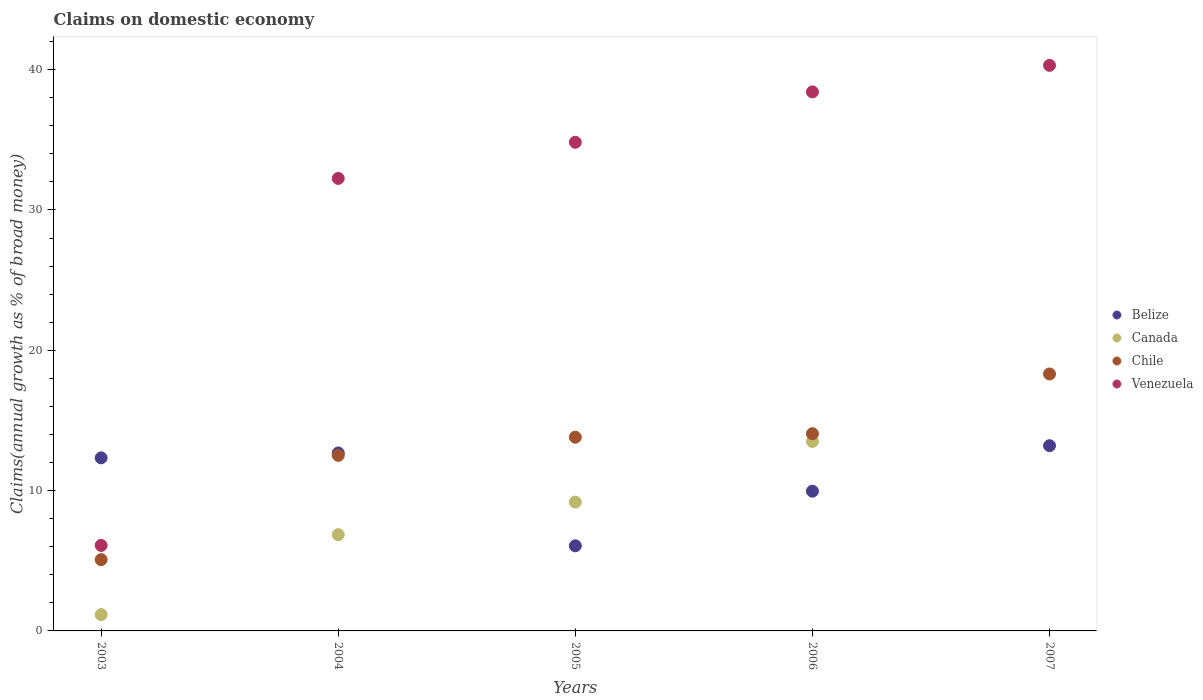What is the percentage of broad money claimed on domestic economy in Canada in 2003?
Offer a terse response. 1.16. Across all years, what is the maximum percentage of broad money claimed on domestic economy in Canada?
Provide a succinct answer. 13.5. Across all years, what is the minimum percentage of broad money claimed on domestic economy in Chile?
Provide a succinct answer. 5.08. What is the total percentage of broad money claimed on domestic economy in Canada in the graph?
Offer a terse response. 30.71. What is the difference between the percentage of broad money claimed on domestic economy in Venezuela in 2003 and that in 2005?
Provide a succinct answer. -28.73. What is the difference between the percentage of broad money claimed on domestic economy in Canada in 2004 and the percentage of broad money claimed on domestic economy in Belize in 2003?
Your answer should be very brief. -5.47. What is the average percentage of broad money claimed on domestic economy in Belize per year?
Your answer should be very brief. 10.85. In the year 2004, what is the difference between the percentage of broad money claimed on domestic economy in Venezuela and percentage of broad money claimed on domestic economy in Belize?
Your answer should be compact. 19.57. In how many years, is the percentage of broad money claimed on domestic economy in Venezuela greater than 40 %?
Ensure brevity in your answer.  1. What is the ratio of the percentage of broad money claimed on domestic economy in Belize in 2006 to that in 2007?
Provide a short and direct response. 0.75. What is the difference between the highest and the second highest percentage of broad money claimed on domestic economy in Canada?
Offer a terse response. 4.32. What is the difference between the highest and the lowest percentage of broad money claimed on domestic economy in Belize?
Provide a short and direct response. 7.14. Is it the case that in every year, the sum of the percentage of broad money claimed on domestic economy in Venezuela and percentage of broad money claimed on domestic economy in Chile  is greater than the sum of percentage of broad money claimed on domestic economy in Canada and percentage of broad money claimed on domestic economy in Belize?
Offer a terse response. No. Does the percentage of broad money claimed on domestic economy in Chile monotonically increase over the years?
Offer a very short reply. Yes. How many years are there in the graph?
Ensure brevity in your answer.  5. What is the difference between two consecutive major ticks on the Y-axis?
Keep it short and to the point. 10. Does the graph contain any zero values?
Give a very brief answer. Yes. Does the graph contain grids?
Provide a short and direct response. No. How many legend labels are there?
Offer a terse response. 4. What is the title of the graph?
Make the answer very short. Claims on domestic economy. Does "Montenegro" appear as one of the legend labels in the graph?
Your answer should be very brief. No. What is the label or title of the X-axis?
Provide a succinct answer. Years. What is the label or title of the Y-axis?
Give a very brief answer. Claims(annual growth as % of broad money). What is the Claims(annual growth as % of broad money) of Belize in 2003?
Your answer should be compact. 12.33. What is the Claims(annual growth as % of broad money) in Canada in 2003?
Ensure brevity in your answer.  1.16. What is the Claims(annual growth as % of broad money) of Chile in 2003?
Give a very brief answer. 5.08. What is the Claims(annual growth as % of broad money) of Venezuela in 2003?
Keep it short and to the point. 6.09. What is the Claims(annual growth as % of broad money) of Belize in 2004?
Provide a short and direct response. 12.68. What is the Claims(annual growth as % of broad money) of Canada in 2004?
Offer a terse response. 6.86. What is the Claims(annual growth as % of broad money) in Chile in 2004?
Give a very brief answer. 12.51. What is the Claims(annual growth as % of broad money) of Venezuela in 2004?
Your response must be concise. 32.25. What is the Claims(annual growth as % of broad money) of Belize in 2005?
Your answer should be compact. 6.07. What is the Claims(annual growth as % of broad money) in Canada in 2005?
Your response must be concise. 9.18. What is the Claims(annual growth as % of broad money) of Chile in 2005?
Keep it short and to the point. 13.81. What is the Claims(annual growth as % of broad money) of Venezuela in 2005?
Offer a very short reply. 34.83. What is the Claims(annual growth as % of broad money) in Belize in 2006?
Offer a very short reply. 9.96. What is the Claims(annual growth as % of broad money) of Canada in 2006?
Keep it short and to the point. 13.5. What is the Claims(annual growth as % of broad money) in Chile in 2006?
Offer a terse response. 14.06. What is the Claims(annual growth as % of broad money) in Venezuela in 2006?
Provide a short and direct response. 38.42. What is the Claims(annual growth as % of broad money) in Belize in 2007?
Your answer should be compact. 13.2. What is the Claims(annual growth as % of broad money) of Canada in 2007?
Provide a short and direct response. 0. What is the Claims(annual growth as % of broad money) of Chile in 2007?
Your response must be concise. 18.31. What is the Claims(annual growth as % of broad money) of Venezuela in 2007?
Give a very brief answer. 40.31. Across all years, what is the maximum Claims(annual growth as % of broad money) in Belize?
Make the answer very short. 13.2. Across all years, what is the maximum Claims(annual growth as % of broad money) in Canada?
Your answer should be compact. 13.5. Across all years, what is the maximum Claims(annual growth as % of broad money) of Chile?
Keep it short and to the point. 18.31. Across all years, what is the maximum Claims(annual growth as % of broad money) of Venezuela?
Give a very brief answer. 40.31. Across all years, what is the minimum Claims(annual growth as % of broad money) of Belize?
Ensure brevity in your answer.  6.07. Across all years, what is the minimum Claims(annual growth as % of broad money) in Chile?
Offer a terse response. 5.08. Across all years, what is the minimum Claims(annual growth as % of broad money) of Venezuela?
Provide a short and direct response. 6.09. What is the total Claims(annual growth as % of broad money) of Belize in the graph?
Give a very brief answer. 54.24. What is the total Claims(annual growth as % of broad money) in Canada in the graph?
Give a very brief answer. 30.71. What is the total Claims(annual growth as % of broad money) of Chile in the graph?
Ensure brevity in your answer.  63.77. What is the total Claims(annual growth as % of broad money) of Venezuela in the graph?
Provide a short and direct response. 151.89. What is the difference between the Claims(annual growth as % of broad money) of Belize in 2003 and that in 2004?
Make the answer very short. -0.35. What is the difference between the Claims(annual growth as % of broad money) of Canada in 2003 and that in 2004?
Make the answer very short. -5.7. What is the difference between the Claims(annual growth as % of broad money) in Chile in 2003 and that in 2004?
Provide a succinct answer. -7.43. What is the difference between the Claims(annual growth as % of broad money) of Venezuela in 2003 and that in 2004?
Provide a succinct answer. -26.16. What is the difference between the Claims(annual growth as % of broad money) in Belize in 2003 and that in 2005?
Give a very brief answer. 6.27. What is the difference between the Claims(annual growth as % of broad money) in Canada in 2003 and that in 2005?
Provide a short and direct response. -8.02. What is the difference between the Claims(annual growth as % of broad money) in Chile in 2003 and that in 2005?
Give a very brief answer. -8.73. What is the difference between the Claims(annual growth as % of broad money) of Venezuela in 2003 and that in 2005?
Ensure brevity in your answer.  -28.73. What is the difference between the Claims(annual growth as % of broad money) of Belize in 2003 and that in 2006?
Provide a succinct answer. 2.38. What is the difference between the Claims(annual growth as % of broad money) of Canada in 2003 and that in 2006?
Give a very brief answer. -12.34. What is the difference between the Claims(annual growth as % of broad money) of Chile in 2003 and that in 2006?
Your response must be concise. -8.98. What is the difference between the Claims(annual growth as % of broad money) in Venezuela in 2003 and that in 2006?
Give a very brief answer. -32.32. What is the difference between the Claims(annual growth as % of broad money) in Belize in 2003 and that in 2007?
Your answer should be compact. -0.87. What is the difference between the Claims(annual growth as % of broad money) in Chile in 2003 and that in 2007?
Your answer should be very brief. -13.23. What is the difference between the Claims(annual growth as % of broad money) in Venezuela in 2003 and that in 2007?
Your answer should be very brief. -34.21. What is the difference between the Claims(annual growth as % of broad money) in Belize in 2004 and that in 2005?
Offer a very short reply. 6.62. What is the difference between the Claims(annual growth as % of broad money) of Canada in 2004 and that in 2005?
Your answer should be compact. -2.32. What is the difference between the Claims(annual growth as % of broad money) of Chile in 2004 and that in 2005?
Keep it short and to the point. -1.29. What is the difference between the Claims(annual growth as % of broad money) in Venezuela in 2004 and that in 2005?
Your answer should be compact. -2.58. What is the difference between the Claims(annual growth as % of broad money) of Belize in 2004 and that in 2006?
Ensure brevity in your answer.  2.72. What is the difference between the Claims(annual growth as % of broad money) in Canada in 2004 and that in 2006?
Keep it short and to the point. -6.64. What is the difference between the Claims(annual growth as % of broad money) in Chile in 2004 and that in 2006?
Your answer should be compact. -1.54. What is the difference between the Claims(annual growth as % of broad money) of Venezuela in 2004 and that in 2006?
Provide a succinct answer. -6.17. What is the difference between the Claims(annual growth as % of broad money) in Belize in 2004 and that in 2007?
Provide a succinct answer. -0.52. What is the difference between the Claims(annual growth as % of broad money) of Chile in 2004 and that in 2007?
Provide a succinct answer. -5.8. What is the difference between the Claims(annual growth as % of broad money) in Venezuela in 2004 and that in 2007?
Give a very brief answer. -8.06. What is the difference between the Claims(annual growth as % of broad money) of Belize in 2005 and that in 2006?
Your answer should be compact. -3.89. What is the difference between the Claims(annual growth as % of broad money) of Canada in 2005 and that in 2006?
Provide a succinct answer. -4.32. What is the difference between the Claims(annual growth as % of broad money) in Chile in 2005 and that in 2006?
Give a very brief answer. -0.25. What is the difference between the Claims(annual growth as % of broad money) in Venezuela in 2005 and that in 2006?
Offer a very short reply. -3.59. What is the difference between the Claims(annual growth as % of broad money) of Belize in 2005 and that in 2007?
Ensure brevity in your answer.  -7.14. What is the difference between the Claims(annual growth as % of broad money) of Chile in 2005 and that in 2007?
Your response must be concise. -4.51. What is the difference between the Claims(annual growth as % of broad money) in Venezuela in 2005 and that in 2007?
Give a very brief answer. -5.48. What is the difference between the Claims(annual growth as % of broad money) of Belize in 2006 and that in 2007?
Your response must be concise. -3.24. What is the difference between the Claims(annual growth as % of broad money) of Chile in 2006 and that in 2007?
Offer a very short reply. -4.25. What is the difference between the Claims(annual growth as % of broad money) in Venezuela in 2006 and that in 2007?
Your response must be concise. -1.89. What is the difference between the Claims(annual growth as % of broad money) of Belize in 2003 and the Claims(annual growth as % of broad money) of Canada in 2004?
Offer a very short reply. 5.47. What is the difference between the Claims(annual growth as % of broad money) of Belize in 2003 and the Claims(annual growth as % of broad money) of Chile in 2004?
Make the answer very short. -0.18. What is the difference between the Claims(annual growth as % of broad money) in Belize in 2003 and the Claims(annual growth as % of broad money) in Venezuela in 2004?
Provide a short and direct response. -19.92. What is the difference between the Claims(annual growth as % of broad money) of Canada in 2003 and the Claims(annual growth as % of broad money) of Chile in 2004?
Ensure brevity in your answer.  -11.35. What is the difference between the Claims(annual growth as % of broad money) in Canada in 2003 and the Claims(annual growth as % of broad money) in Venezuela in 2004?
Make the answer very short. -31.09. What is the difference between the Claims(annual growth as % of broad money) in Chile in 2003 and the Claims(annual growth as % of broad money) in Venezuela in 2004?
Provide a succinct answer. -27.17. What is the difference between the Claims(annual growth as % of broad money) in Belize in 2003 and the Claims(annual growth as % of broad money) in Canada in 2005?
Provide a short and direct response. 3.15. What is the difference between the Claims(annual growth as % of broad money) in Belize in 2003 and the Claims(annual growth as % of broad money) in Chile in 2005?
Offer a very short reply. -1.47. What is the difference between the Claims(annual growth as % of broad money) of Belize in 2003 and the Claims(annual growth as % of broad money) of Venezuela in 2005?
Give a very brief answer. -22.49. What is the difference between the Claims(annual growth as % of broad money) in Canada in 2003 and the Claims(annual growth as % of broad money) in Chile in 2005?
Provide a short and direct response. -12.64. What is the difference between the Claims(annual growth as % of broad money) of Canada in 2003 and the Claims(annual growth as % of broad money) of Venezuela in 2005?
Provide a short and direct response. -33.66. What is the difference between the Claims(annual growth as % of broad money) in Chile in 2003 and the Claims(annual growth as % of broad money) in Venezuela in 2005?
Give a very brief answer. -29.75. What is the difference between the Claims(annual growth as % of broad money) in Belize in 2003 and the Claims(annual growth as % of broad money) in Canada in 2006?
Ensure brevity in your answer.  -1.17. What is the difference between the Claims(annual growth as % of broad money) in Belize in 2003 and the Claims(annual growth as % of broad money) in Chile in 2006?
Provide a short and direct response. -1.72. What is the difference between the Claims(annual growth as % of broad money) in Belize in 2003 and the Claims(annual growth as % of broad money) in Venezuela in 2006?
Keep it short and to the point. -26.08. What is the difference between the Claims(annual growth as % of broad money) in Canada in 2003 and the Claims(annual growth as % of broad money) in Chile in 2006?
Your answer should be very brief. -12.89. What is the difference between the Claims(annual growth as % of broad money) in Canada in 2003 and the Claims(annual growth as % of broad money) in Venezuela in 2006?
Offer a terse response. -37.25. What is the difference between the Claims(annual growth as % of broad money) of Chile in 2003 and the Claims(annual growth as % of broad money) of Venezuela in 2006?
Provide a succinct answer. -33.34. What is the difference between the Claims(annual growth as % of broad money) of Belize in 2003 and the Claims(annual growth as % of broad money) of Chile in 2007?
Your answer should be compact. -5.98. What is the difference between the Claims(annual growth as % of broad money) of Belize in 2003 and the Claims(annual growth as % of broad money) of Venezuela in 2007?
Your answer should be compact. -27.97. What is the difference between the Claims(annual growth as % of broad money) in Canada in 2003 and the Claims(annual growth as % of broad money) in Chile in 2007?
Keep it short and to the point. -17.15. What is the difference between the Claims(annual growth as % of broad money) in Canada in 2003 and the Claims(annual growth as % of broad money) in Venezuela in 2007?
Give a very brief answer. -39.15. What is the difference between the Claims(annual growth as % of broad money) in Chile in 2003 and the Claims(annual growth as % of broad money) in Venezuela in 2007?
Keep it short and to the point. -35.23. What is the difference between the Claims(annual growth as % of broad money) in Belize in 2004 and the Claims(annual growth as % of broad money) in Canada in 2005?
Provide a succinct answer. 3.5. What is the difference between the Claims(annual growth as % of broad money) in Belize in 2004 and the Claims(annual growth as % of broad money) in Chile in 2005?
Give a very brief answer. -1.12. What is the difference between the Claims(annual growth as % of broad money) in Belize in 2004 and the Claims(annual growth as % of broad money) in Venezuela in 2005?
Your response must be concise. -22.14. What is the difference between the Claims(annual growth as % of broad money) in Canada in 2004 and the Claims(annual growth as % of broad money) in Chile in 2005?
Offer a very short reply. -6.95. What is the difference between the Claims(annual growth as % of broad money) in Canada in 2004 and the Claims(annual growth as % of broad money) in Venezuela in 2005?
Offer a very short reply. -27.96. What is the difference between the Claims(annual growth as % of broad money) of Chile in 2004 and the Claims(annual growth as % of broad money) of Venezuela in 2005?
Make the answer very short. -22.31. What is the difference between the Claims(annual growth as % of broad money) of Belize in 2004 and the Claims(annual growth as % of broad money) of Canada in 2006?
Ensure brevity in your answer.  -0.82. What is the difference between the Claims(annual growth as % of broad money) of Belize in 2004 and the Claims(annual growth as % of broad money) of Chile in 2006?
Offer a very short reply. -1.37. What is the difference between the Claims(annual growth as % of broad money) in Belize in 2004 and the Claims(annual growth as % of broad money) in Venezuela in 2006?
Provide a succinct answer. -25.73. What is the difference between the Claims(annual growth as % of broad money) in Canada in 2004 and the Claims(annual growth as % of broad money) in Chile in 2006?
Offer a terse response. -7.2. What is the difference between the Claims(annual growth as % of broad money) of Canada in 2004 and the Claims(annual growth as % of broad money) of Venezuela in 2006?
Provide a succinct answer. -31.55. What is the difference between the Claims(annual growth as % of broad money) in Chile in 2004 and the Claims(annual growth as % of broad money) in Venezuela in 2006?
Offer a very short reply. -25.9. What is the difference between the Claims(annual growth as % of broad money) of Belize in 2004 and the Claims(annual growth as % of broad money) of Chile in 2007?
Give a very brief answer. -5.63. What is the difference between the Claims(annual growth as % of broad money) of Belize in 2004 and the Claims(annual growth as % of broad money) of Venezuela in 2007?
Provide a short and direct response. -27.63. What is the difference between the Claims(annual growth as % of broad money) in Canada in 2004 and the Claims(annual growth as % of broad money) in Chile in 2007?
Provide a succinct answer. -11.45. What is the difference between the Claims(annual growth as % of broad money) in Canada in 2004 and the Claims(annual growth as % of broad money) in Venezuela in 2007?
Ensure brevity in your answer.  -33.45. What is the difference between the Claims(annual growth as % of broad money) in Chile in 2004 and the Claims(annual growth as % of broad money) in Venezuela in 2007?
Make the answer very short. -27.8. What is the difference between the Claims(annual growth as % of broad money) of Belize in 2005 and the Claims(annual growth as % of broad money) of Canada in 2006?
Give a very brief answer. -7.44. What is the difference between the Claims(annual growth as % of broad money) of Belize in 2005 and the Claims(annual growth as % of broad money) of Chile in 2006?
Your answer should be compact. -7.99. What is the difference between the Claims(annual growth as % of broad money) of Belize in 2005 and the Claims(annual growth as % of broad money) of Venezuela in 2006?
Offer a terse response. -32.35. What is the difference between the Claims(annual growth as % of broad money) of Canada in 2005 and the Claims(annual growth as % of broad money) of Chile in 2006?
Your answer should be compact. -4.88. What is the difference between the Claims(annual growth as % of broad money) in Canada in 2005 and the Claims(annual growth as % of broad money) in Venezuela in 2006?
Provide a succinct answer. -29.23. What is the difference between the Claims(annual growth as % of broad money) of Chile in 2005 and the Claims(annual growth as % of broad money) of Venezuela in 2006?
Ensure brevity in your answer.  -24.61. What is the difference between the Claims(annual growth as % of broad money) in Belize in 2005 and the Claims(annual growth as % of broad money) in Chile in 2007?
Make the answer very short. -12.25. What is the difference between the Claims(annual growth as % of broad money) in Belize in 2005 and the Claims(annual growth as % of broad money) in Venezuela in 2007?
Provide a succinct answer. -34.24. What is the difference between the Claims(annual growth as % of broad money) of Canada in 2005 and the Claims(annual growth as % of broad money) of Chile in 2007?
Your answer should be very brief. -9.13. What is the difference between the Claims(annual growth as % of broad money) of Canada in 2005 and the Claims(annual growth as % of broad money) of Venezuela in 2007?
Keep it short and to the point. -31.13. What is the difference between the Claims(annual growth as % of broad money) in Chile in 2005 and the Claims(annual growth as % of broad money) in Venezuela in 2007?
Ensure brevity in your answer.  -26.5. What is the difference between the Claims(annual growth as % of broad money) of Belize in 2006 and the Claims(annual growth as % of broad money) of Chile in 2007?
Your response must be concise. -8.35. What is the difference between the Claims(annual growth as % of broad money) in Belize in 2006 and the Claims(annual growth as % of broad money) in Venezuela in 2007?
Make the answer very short. -30.35. What is the difference between the Claims(annual growth as % of broad money) of Canada in 2006 and the Claims(annual growth as % of broad money) of Chile in 2007?
Ensure brevity in your answer.  -4.81. What is the difference between the Claims(annual growth as % of broad money) in Canada in 2006 and the Claims(annual growth as % of broad money) in Venezuela in 2007?
Give a very brief answer. -26.8. What is the difference between the Claims(annual growth as % of broad money) in Chile in 2006 and the Claims(annual growth as % of broad money) in Venezuela in 2007?
Offer a very short reply. -26.25. What is the average Claims(annual growth as % of broad money) in Belize per year?
Ensure brevity in your answer.  10.85. What is the average Claims(annual growth as % of broad money) in Canada per year?
Provide a short and direct response. 6.14. What is the average Claims(annual growth as % of broad money) in Chile per year?
Offer a very short reply. 12.75. What is the average Claims(annual growth as % of broad money) of Venezuela per year?
Provide a short and direct response. 30.38. In the year 2003, what is the difference between the Claims(annual growth as % of broad money) in Belize and Claims(annual growth as % of broad money) in Canada?
Provide a short and direct response. 11.17. In the year 2003, what is the difference between the Claims(annual growth as % of broad money) of Belize and Claims(annual growth as % of broad money) of Chile?
Your answer should be very brief. 7.25. In the year 2003, what is the difference between the Claims(annual growth as % of broad money) of Belize and Claims(annual growth as % of broad money) of Venezuela?
Your response must be concise. 6.24. In the year 2003, what is the difference between the Claims(annual growth as % of broad money) in Canada and Claims(annual growth as % of broad money) in Chile?
Provide a succinct answer. -3.92. In the year 2003, what is the difference between the Claims(annual growth as % of broad money) of Canada and Claims(annual growth as % of broad money) of Venezuela?
Keep it short and to the point. -4.93. In the year 2003, what is the difference between the Claims(annual growth as % of broad money) of Chile and Claims(annual growth as % of broad money) of Venezuela?
Your answer should be compact. -1.01. In the year 2004, what is the difference between the Claims(annual growth as % of broad money) of Belize and Claims(annual growth as % of broad money) of Canada?
Offer a very short reply. 5.82. In the year 2004, what is the difference between the Claims(annual growth as % of broad money) of Belize and Claims(annual growth as % of broad money) of Chile?
Your answer should be compact. 0.17. In the year 2004, what is the difference between the Claims(annual growth as % of broad money) in Belize and Claims(annual growth as % of broad money) in Venezuela?
Ensure brevity in your answer.  -19.57. In the year 2004, what is the difference between the Claims(annual growth as % of broad money) in Canada and Claims(annual growth as % of broad money) in Chile?
Ensure brevity in your answer.  -5.65. In the year 2004, what is the difference between the Claims(annual growth as % of broad money) in Canada and Claims(annual growth as % of broad money) in Venezuela?
Offer a terse response. -25.39. In the year 2004, what is the difference between the Claims(annual growth as % of broad money) in Chile and Claims(annual growth as % of broad money) in Venezuela?
Ensure brevity in your answer.  -19.74. In the year 2005, what is the difference between the Claims(annual growth as % of broad money) in Belize and Claims(annual growth as % of broad money) in Canada?
Give a very brief answer. -3.11. In the year 2005, what is the difference between the Claims(annual growth as % of broad money) of Belize and Claims(annual growth as % of broad money) of Chile?
Your answer should be compact. -7.74. In the year 2005, what is the difference between the Claims(annual growth as % of broad money) of Belize and Claims(annual growth as % of broad money) of Venezuela?
Ensure brevity in your answer.  -28.76. In the year 2005, what is the difference between the Claims(annual growth as % of broad money) in Canada and Claims(annual growth as % of broad money) in Chile?
Make the answer very short. -4.63. In the year 2005, what is the difference between the Claims(annual growth as % of broad money) of Canada and Claims(annual growth as % of broad money) of Venezuela?
Your answer should be compact. -25.64. In the year 2005, what is the difference between the Claims(annual growth as % of broad money) of Chile and Claims(annual growth as % of broad money) of Venezuela?
Make the answer very short. -21.02. In the year 2006, what is the difference between the Claims(annual growth as % of broad money) in Belize and Claims(annual growth as % of broad money) in Canada?
Your response must be concise. -3.55. In the year 2006, what is the difference between the Claims(annual growth as % of broad money) of Belize and Claims(annual growth as % of broad money) of Chile?
Give a very brief answer. -4.1. In the year 2006, what is the difference between the Claims(annual growth as % of broad money) in Belize and Claims(annual growth as % of broad money) in Venezuela?
Make the answer very short. -28.46. In the year 2006, what is the difference between the Claims(annual growth as % of broad money) of Canada and Claims(annual growth as % of broad money) of Chile?
Your response must be concise. -0.55. In the year 2006, what is the difference between the Claims(annual growth as % of broad money) of Canada and Claims(annual growth as % of broad money) of Venezuela?
Your answer should be compact. -24.91. In the year 2006, what is the difference between the Claims(annual growth as % of broad money) of Chile and Claims(annual growth as % of broad money) of Venezuela?
Offer a terse response. -24.36. In the year 2007, what is the difference between the Claims(annual growth as % of broad money) in Belize and Claims(annual growth as % of broad money) in Chile?
Ensure brevity in your answer.  -5.11. In the year 2007, what is the difference between the Claims(annual growth as % of broad money) in Belize and Claims(annual growth as % of broad money) in Venezuela?
Make the answer very short. -27.11. In the year 2007, what is the difference between the Claims(annual growth as % of broad money) of Chile and Claims(annual growth as % of broad money) of Venezuela?
Make the answer very short. -22. What is the ratio of the Claims(annual growth as % of broad money) in Belize in 2003 to that in 2004?
Provide a succinct answer. 0.97. What is the ratio of the Claims(annual growth as % of broad money) of Canada in 2003 to that in 2004?
Your answer should be very brief. 0.17. What is the ratio of the Claims(annual growth as % of broad money) of Chile in 2003 to that in 2004?
Provide a succinct answer. 0.41. What is the ratio of the Claims(annual growth as % of broad money) of Venezuela in 2003 to that in 2004?
Provide a short and direct response. 0.19. What is the ratio of the Claims(annual growth as % of broad money) in Belize in 2003 to that in 2005?
Your answer should be very brief. 2.03. What is the ratio of the Claims(annual growth as % of broad money) in Canada in 2003 to that in 2005?
Provide a succinct answer. 0.13. What is the ratio of the Claims(annual growth as % of broad money) of Chile in 2003 to that in 2005?
Provide a short and direct response. 0.37. What is the ratio of the Claims(annual growth as % of broad money) of Venezuela in 2003 to that in 2005?
Ensure brevity in your answer.  0.17. What is the ratio of the Claims(annual growth as % of broad money) in Belize in 2003 to that in 2006?
Your response must be concise. 1.24. What is the ratio of the Claims(annual growth as % of broad money) of Canada in 2003 to that in 2006?
Your response must be concise. 0.09. What is the ratio of the Claims(annual growth as % of broad money) of Chile in 2003 to that in 2006?
Offer a very short reply. 0.36. What is the ratio of the Claims(annual growth as % of broad money) of Venezuela in 2003 to that in 2006?
Provide a succinct answer. 0.16. What is the ratio of the Claims(annual growth as % of broad money) in Belize in 2003 to that in 2007?
Ensure brevity in your answer.  0.93. What is the ratio of the Claims(annual growth as % of broad money) in Chile in 2003 to that in 2007?
Make the answer very short. 0.28. What is the ratio of the Claims(annual growth as % of broad money) of Venezuela in 2003 to that in 2007?
Ensure brevity in your answer.  0.15. What is the ratio of the Claims(annual growth as % of broad money) of Belize in 2004 to that in 2005?
Provide a short and direct response. 2.09. What is the ratio of the Claims(annual growth as % of broad money) in Canada in 2004 to that in 2005?
Ensure brevity in your answer.  0.75. What is the ratio of the Claims(annual growth as % of broad money) of Chile in 2004 to that in 2005?
Your answer should be very brief. 0.91. What is the ratio of the Claims(annual growth as % of broad money) of Venezuela in 2004 to that in 2005?
Your response must be concise. 0.93. What is the ratio of the Claims(annual growth as % of broad money) of Belize in 2004 to that in 2006?
Make the answer very short. 1.27. What is the ratio of the Claims(annual growth as % of broad money) in Canada in 2004 to that in 2006?
Make the answer very short. 0.51. What is the ratio of the Claims(annual growth as % of broad money) of Chile in 2004 to that in 2006?
Offer a very short reply. 0.89. What is the ratio of the Claims(annual growth as % of broad money) of Venezuela in 2004 to that in 2006?
Your response must be concise. 0.84. What is the ratio of the Claims(annual growth as % of broad money) of Belize in 2004 to that in 2007?
Keep it short and to the point. 0.96. What is the ratio of the Claims(annual growth as % of broad money) of Chile in 2004 to that in 2007?
Your response must be concise. 0.68. What is the ratio of the Claims(annual growth as % of broad money) in Venezuela in 2004 to that in 2007?
Your answer should be very brief. 0.8. What is the ratio of the Claims(annual growth as % of broad money) in Belize in 2005 to that in 2006?
Offer a terse response. 0.61. What is the ratio of the Claims(annual growth as % of broad money) of Canada in 2005 to that in 2006?
Keep it short and to the point. 0.68. What is the ratio of the Claims(annual growth as % of broad money) in Chile in 2005 to that in 2006?
Make the answer very short. 0.98. What is the ratio of the Claims(annual growth as % of broad money) in Venezuela in 2005 to that in 2006?
Offer a terse response. 0.91. What is the ratio of the Claims(annual growth as % of broad money) of Belize in 2005 to that in 2007?
Ensure brevity in your answer.  0.46. What is the ratio of the Claims(annual growth as % of broad money) of Chile in 2005 to that in 2007?
Your answer should be compact. 0.75. What is the ratio of the Claims(annual growth as % of broad money) of Venezuela in 2005 to that in 2007?
Offer a very short reply. 0.86. What is the ratio of the Claims(annual growth as % of broad money) in Belize in 2006 to that in 2007?
Offer a terse response. 0.75. What is the ratio of the Claims(annual growth as % of broad money) of Chile in 2006 to that in 2007?
Give a very brief answer. 0.77. What is the ratio of the Claims(annual growth as % of broad money) of Venezuela in 2006 to that in 2007?
Your response must be concise. 0.95. What is the difference between the highest and the second highest Claims(annual growth as % of broad money) in Belize?
Give a very brief answer. 0.52. What is the difference between the highest and the second highest Claims(annual growth as % of broad money) in Canada?
Your answer should be compact. 4.32. What is the difference between the highest and the second highest Claims(annual growth as % of broad money) of Chile?
Provide a succinct answer. 4.25. What is the difference between the highest and the second highest Claims(annual growth as % of broad money) in Venezuela?
Keep it short and to the point. 1.89. What is the difference between the highest and the lowest Claims(annual growth as % of broad money) in Belize?
Make the answer very short. 7.14. What is the difference between the highest and the lowest Claims(annual growth as % of broad money) of Canada?
Give a very brief answer. 13.5. What is the difference between the highest and the lowest Claims(annual growth as % of broad money) of Chile?
Ensure brevity in your answer.  13.23. What is the difference between the highest and the lowest Claims(annual growth as % of broad money) of Venezuela?
Keep it short and to the point. 34.21. 